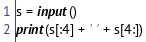<code> <loc_0><loc_0><loc_500><loc_500><_Python_>s = input()
print(s[:4] + ' ' + s[4:])</code> 